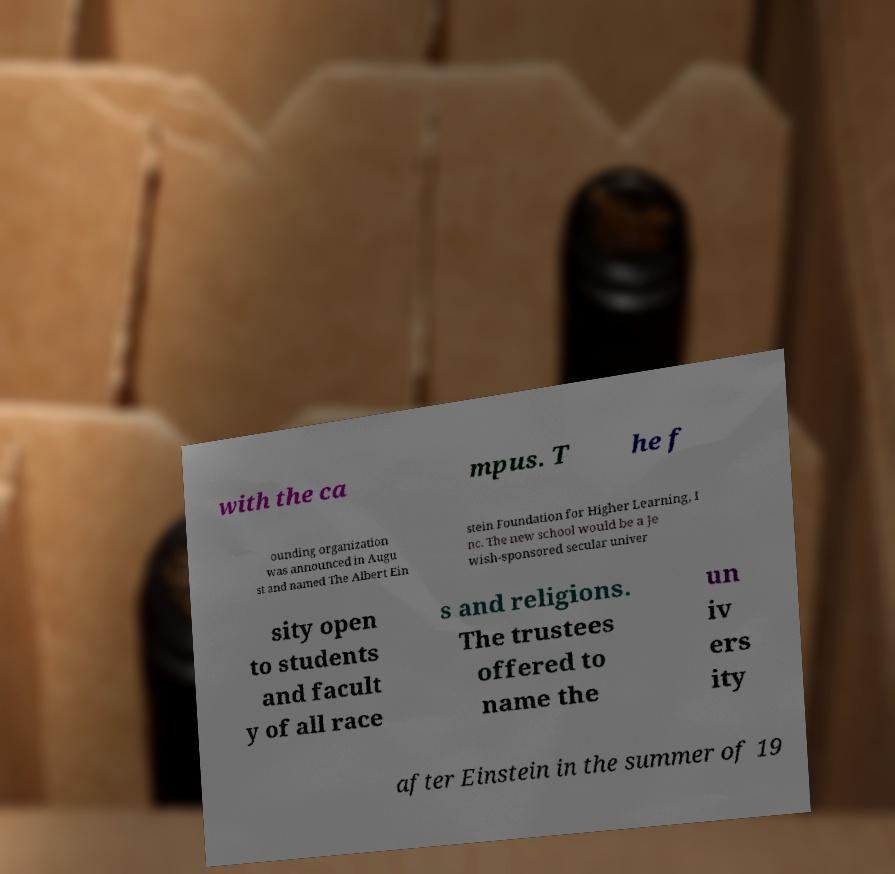Could you extract and type out the text from this image? with the ca mpus. T he f ounding organization was announced in Augu st and named The Albert Ein stein Foundation for Higher Learning, I nc. The new school would be a Je wish-sponsored secular univer sity open to students and facult y of all race s and religions. The trustees offered to name the un iv ers ity after Einstein in the summer of 19 